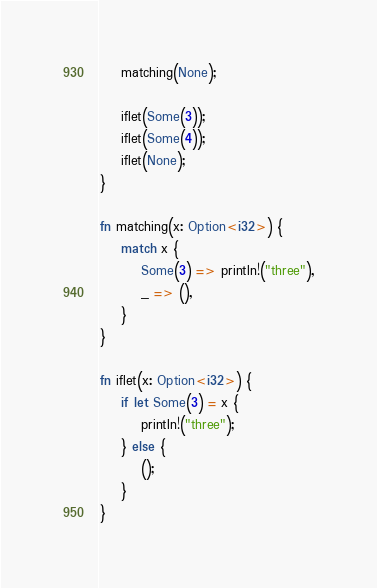<code> <loc_0><loc_0><loc_500><loc_500><_Rust_>    matching(None);

    iflet(Some(3));
    iflet(Some(4));
    iflet(None);
}

fn matching(x: Option<i32>) {
    match x {
        Some(3) => println!("three"),
        _ => (),
    }
}

fn iflet(x: Option<i32>) {
    if let Some(3) = x {
        println!("three");
    } else {
        ();
    }
}</code> 